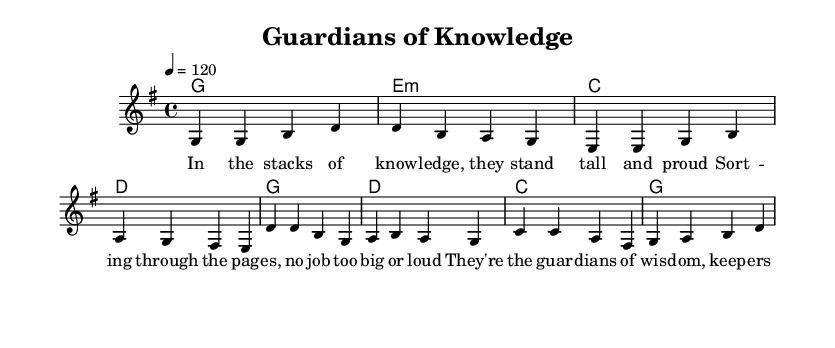What is the key signature of this music? The key signature in the sheet music is G major, which contains one sharp (F#). It is indicated at the beginning of the staff.
Answer: G major What is the time signature of this music? The time signature is shown at the beginning of the sheet music. It indicates that there are four beats per measure.
Answer: 4/4 What is the tempo of the piece? The tempo is found in the score, where it indicates the speed at which the music should be played. It states "4 = 120", meaning there are 120 beats per minute.
Answer: 120 How many measures are in the verse? By counting the measures in the melody section labeled as 'Verse', there are four distinct measures.
Answer: 4 What is the first lyrical line of the chorus? The lyrics are provided under the melody, and the first line of the chorus reads "They're the guardians of wisdom."
Answer: They're the guardians of wisdom What role do the librarians and archivists play in the lyrics? The lyrics describe librarians and archivists as "guardians of wisdom" who preserve history, showing their importance in the community and their unsung hero status.
Answer: Guardians of wisdom How many distinct chords are used in the verse? By examining the chord symbols provided in the harmonies, there are four different chords outlined for the verse section.
Answer: 4 